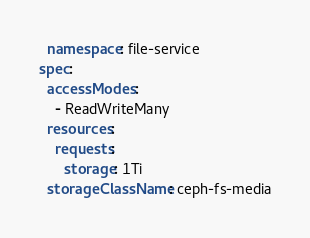<code> <loc_0><loc_0><loc_500><loc_500><_YAML_>  namespace: file-service
spec:
  accessModes:
    - ReadWriteMany
  resources:
    requests:
      storage: 1Ti
  storageClassName: ceph-fs-media
</code> 